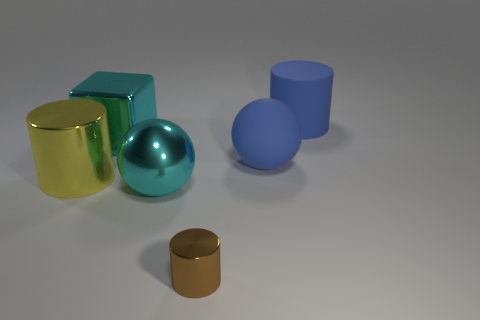What number of objects are big gray rubber cylinders or large cyan shiny things to the left of the big cyan sphere?
Your answer should be very brief. 1. Is there another thing of the same shape as the tiny object?
Provide a short and direct response. Yes. How big is the metallic sphere in front of the big cyan shiny object that is behind the yellow object?
Your response must be concise. Large. Do the big rubber sphere and the small cylinder have the same color?
Offer a terse response. No. What number of rubber things are either large blue cylinders or large spheres?
Provide a short and direct response. 2. How many large cyan metallic objects are there?
Make the answer very short. 2. Does the cyan object that is right of the metallic block have the same material as the big cylinder that is in front of the big metallic cube?
Keep it short and to the point. Yes. What is the color of the large shiny thing that is the same shape as the tiny brown thing?
Keep it short and to the point. Yellow. What is the material of the blue object on the left side of the blue rubber thing behind the large block?
Keep it short and to the point. Rubber. There is a large yellow metal object that is behind the big cyan metallic sphere; is its shape the same as the cyan object behind the large yellow object?
Provide a short and direct response. No. 